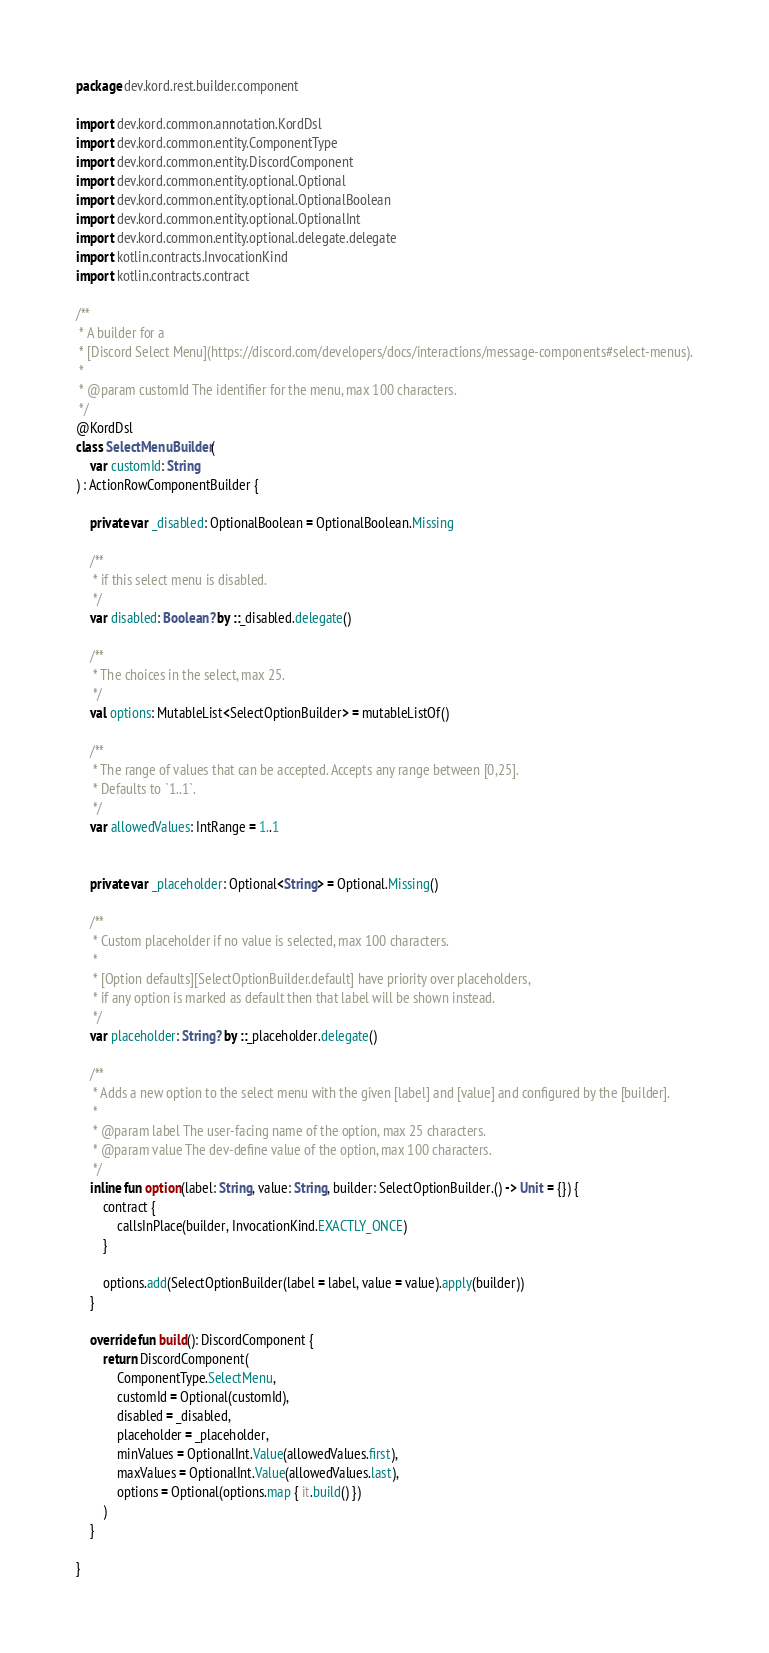Convert code to text. <code><loc_0><loc_0><loc_500><loc_500><_Kotlin_>package dev.kord.rest.builder.component

import dev.kord.common.annotation.KordDsl
import dev.kord.common.entity.ComponentType
import dev.kord.common.entity.DiscordComponent
import dev.kord.common.entity.optional.Optional
import dev.kord.common.entity.optional.OptionalBoolean
import dev.kord.common.entity.optional.OptionalInt
import dev.kord.common.entity.optional.delegate.delegate
import kotlin.contracts.InvocationKind
import kotlin.contracts.contract

/**
 * A builder for a
 * [Discord Select Menu](https://discord.com/developers/docs/interactions/message-components#select-menus).
 *
 * @param customId The identifier for the menu, max 100 characters.
 */
@KordDsl
class SelectMenuBuilder(
    var customId: String
) : ActionRowComponentBuilder {

    private var _disabled: OptionalBoolean = OptionalBoolean.Missing

    /**
     * if this select menu is disabled.
     */
    var disabled: Boolean? by ::_disabled.delegate()

    /**
     * The choices in the select, max 25.
     */
    val options: MutableList<SelectOptionBuilder> = mutableListOf()

    /**
     * The range of values that can be accepted. Accepts any range between [0,25].
     * Defaults to `1..1`.
     */
    var allowedValues: IntRange = 1..1


    private var _placeholder: Optional<String> = Optional.Missing()

    /**
     * Custom placeholder if no value is selected, max 100 characters.
     *
     * [Option defaults][SelectOptionBuilder.default] have priority over placeholders,
     * if any option is marked as default then that label will be shown instead.
     */
    var placeholder: String? by ::_placeholder.delegate()

    /**
     * Adds a new option to the select menu with the given [label] and [value] and configured by the [builder].
     *
     * @param label The user-facing name of the option, max 25 characters.
     * @param value The dev-define value of the option, max 100 characters.
     */
    inline fun option(label: String, value: String, builder: SelectOptionBuilder.() -> Unit = {}) {
        contract {
            callsInPlace(builder, InvocationKind.EXACTLY_ONCE)
        }

        options.add(SelectOptionBuilder(label = label, value = value).apply(builder))
    }

    override fun build(): DiscordComponent {
        return DiscordComponent(
            ComponentType.SelectMenu,
            customId = Optional(customId),
            disabled = _disabled,
            placeholder = _placeholder,
            minValues = OptionalInt.Value(allowedValues.first),
            maxValues = OptionalInt.Value(allowedValues.last),
            options = Optional(options.map { it.build() })
        )
    }

}
</code> 